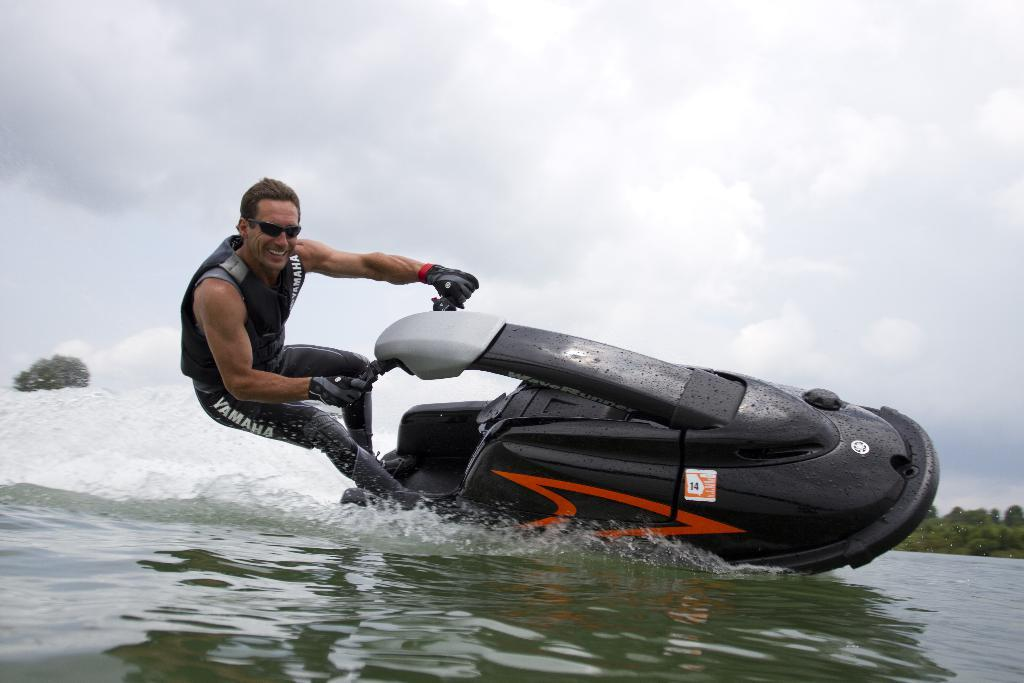What is the main subject of the image? There is a person in the image. What is the person wearing? The person is wearing a jacket, glasses, and gloves. What activity is the person engaged in? The person is riding a water bike. Where is the water bike located? The water bike is on the water. What can be seen in the background of the image? There are trees and a cloudy sky in the background of the image. What type of plants can be seen growing on the water bike in the image? There are no plants visible on the water bike in the image. What type of food is the person cooking on the water bike in the image? There is no cooking activity or food visible in the image. 